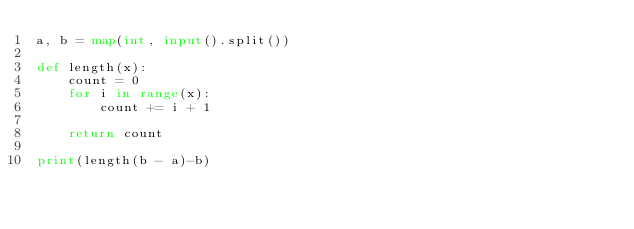<code> <loc_0><loc_0><loc_500><loc_500><_Python_>a, b = map(int, input().split())

def length(x):
    count = 0
    for i in range(x):
        count += i + 1

    return count

print(length(b - a)-b)
</code> 